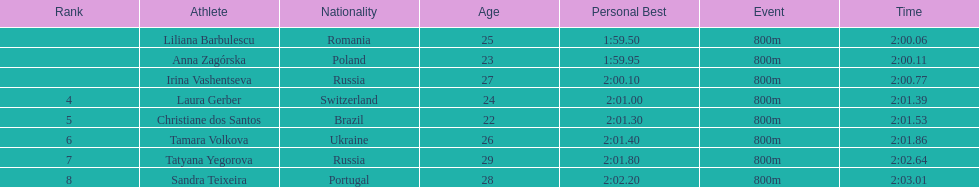Would you be able to parse every entry in this table? {'header': ['Rank', 'Athlete', 'Nationality', 'Age', 'Personal Best', 'Event', 'Time'], 'rows': [['', 'Liliana Barbulescu', 'Romania', '25 ', '1:59.50     ', '800m ', '2:00.06'], ['', 'Anna Zagórska', 'Poland', '23 ', '1:59.95     ', '800m ', '2:00.11'], ['', 'Irina Vashentseva', 'Russia', '27 ', '2:00.10     ', '800m ', '2:00.77'], ['4', 'Laura Gerber', 'Switzerland', '24', '2:01.00   ', '800m ', '2:01.39'], ['5', 'Christiane dos Santos', 'Brazil', '22', '2:01.30   ', '800m ', '2:01.53'], ['6', 'Tamara Volkova', 'Ukraine', '26 ', '2:01.40     ', '800m ', '2:01.86'], ['7', 'Tatyana Yegorova', 'Russia', '29 ', '2:01.80     ', '800m ', '2:02.64'], ['8', 'Sandra Teixeira', 'Portugal', '28 ', '2:02.20     ', '800m ', '2:03.01']]} What is the number of russian participants in this set of semifinals? 2. 